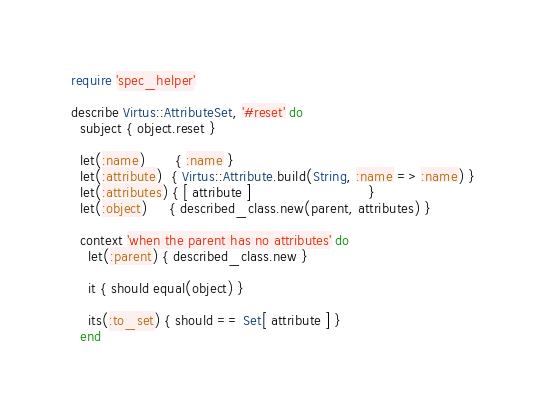Convert code to text. <code><loc_0><loc_0><loc_500><loc_500><_Ruby_>require 'spec_helper'

describe Virtus::AttributeSet, '#reset' do
  subject { object.reset }

  let(:name)       { :name }
  let(:attribute)  { Virtus::Attribute.build(String, :name => :name) }
  let(:attributes) { [ attribute ]                           }
  let(:object)     { described_class.new(parent, attributes) }

  context 'when the parent has no attributes' do
    let(:parent) { described_class.new }

    it { should equal(object) }

    its(:to_set) { should == Set[ attribute ] }
  end
</code> 